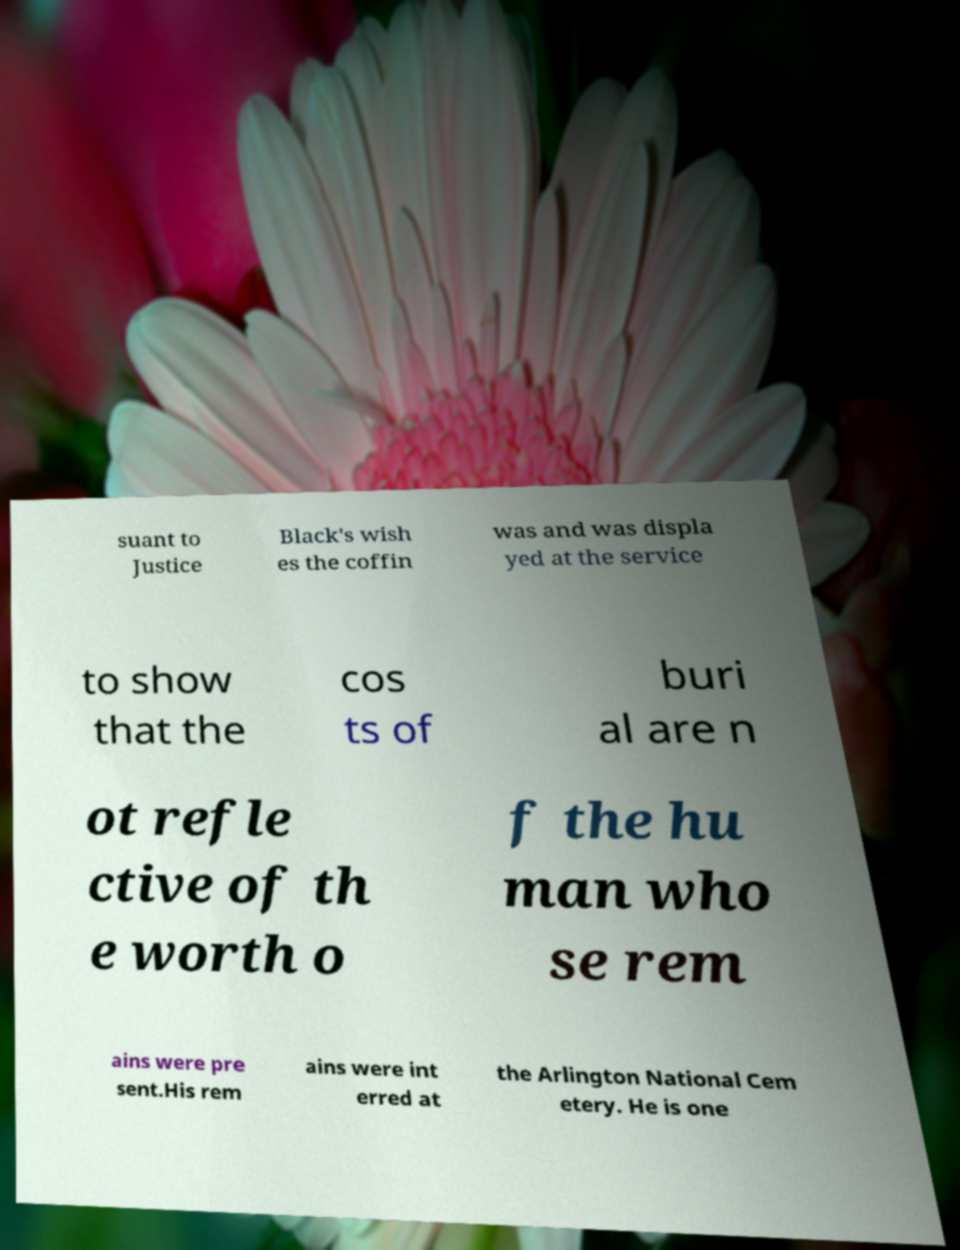What messages or text are displayed in this image? I need them in a readable, typed format. suant to Justice Black's wish es the coffin was and was displa yed at the service to show that the cos ts of buri al are n ot refle ctive of th e worth o f the hu man who se rem ains were pre sent.His rem ains were int erred at the Arlington National Cem etery. He is one 